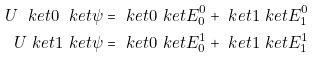Convert formula to latex. <formula><loc_0><loc_0><loc_500><loc_500>U \ k e t 0 \ k e t \psi & = \ k e t 0 \ k e t { E _ { 0 } ^ { 0 } } + \ k e t 1 \ k e t { E _ { 1 } ^ { 0 } } \\ U \ k e t 1 \ k e t \psi & = \ k e t 0 \ k e t { E _ { 0 } ^ { 1 } } + \ k e t 1 \ k e t { E _ { 1 } ^ { 1 } }</formula> 